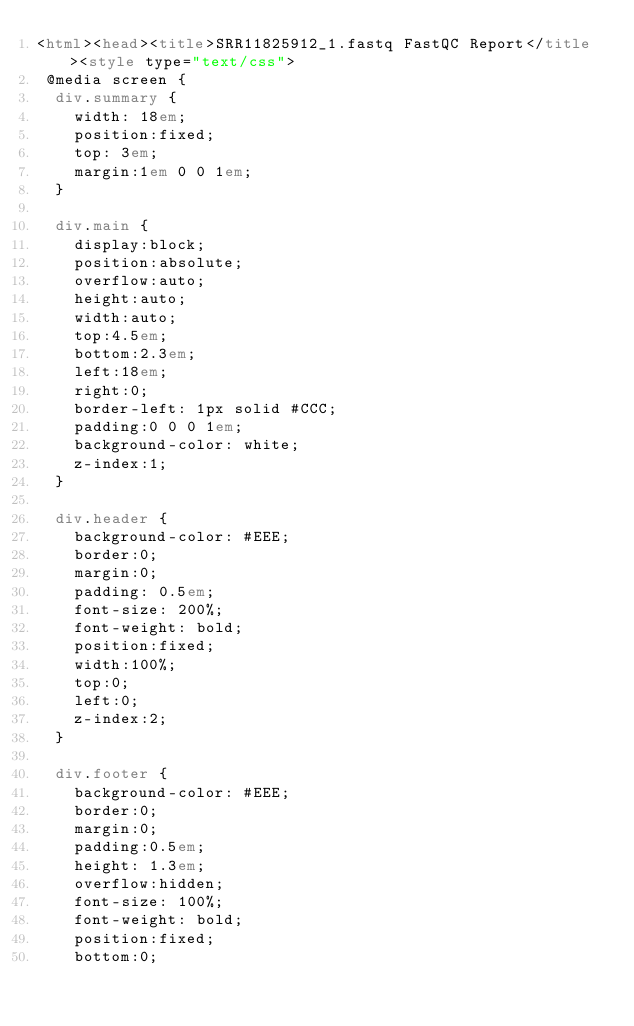Convert code to text. <code><loc_0><loc_0><loc_500><loc_500><_HTML_><html><head><title>SRR11825912_1.fastq FastQC Report</title><style type="text/css">
 @media screen {
  div.summary {
    width: 18em;
    position:fixed;
    top: 3em;
    margin:1em 0 0 1em;
  }
  
  div.main {
    display:block;
    position:absolute;
    overflow:auto;
    height:auto;
    width:auto;
    top:4.5em;
    bottom:2.3em;
    left:18em;
    right:0;
    border-left: 1px solid #CCC;
    padding:0 0 0 1em;
    background-color: white;
    z-index:1;
  }
  
  div.header {
    background-color: #EEE;
    border:0;
    margin:0;
    padding: 0.5em;
    font-size: 200%;
    font-weight: bold;
    position:fixed;
    width:100%;
    top:0;
    left:0;
    z-index:2;
  }

  div.footer {
    background-color: #EEE;
    border:0;
    margin:0;
	padding:0.5em;
    height: 1.3em;
	overflow:hidden;
    font-size: 100%;
    font-weight: bold;
    position:fixed;
    bottom:0;</code> 